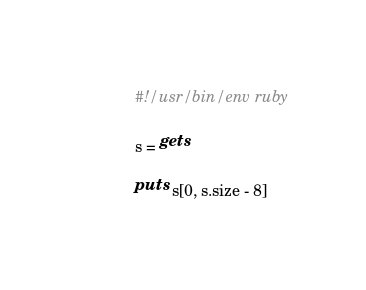<code> <loc_0><loc_0><loc_500><loc_500><_Ruby_>#!/usr/bin/env ruby

s = gets

puts s[0, s.size - 8]
</code> 